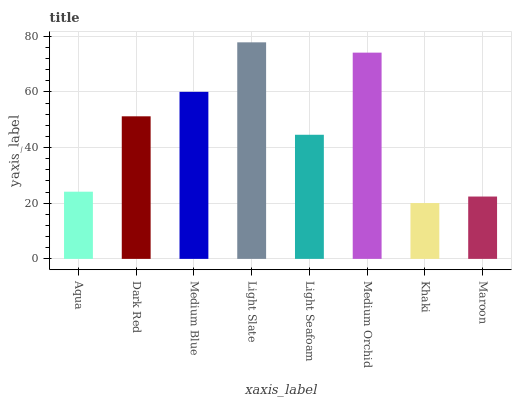Is Khaki the minimum?
Answer yes or no. Yes. Is Light Slate the maximum?
Answer yes or no. Yes. Is Dark Red the minimum?
Answer yes or no. No. Is Dark Red the maximum?
Answer yes or no. No. Is Dark Red greater than Aqua?
Answer yes or no. Yes. Is Aqua less than Dark Red?
Answer yes or no. Yes. Is Aqua greater than Dark Red?
Answer yes or no. No. Is Dark Red less than Aqua?
Answer yes or no. No. Is Dark Red the high median?
Answer yes or no. Yes. Is Light Seafoam the low median?
Answer yes or no. Yes. Is Khaki the high median?
Answer yes or no. No. Is Medium Blue the low median?
Answer yes or no. No. 